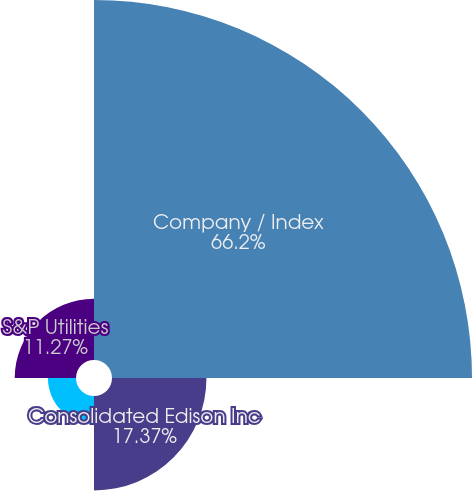Convert chart to OTSL. <chart><loc_0><loc_0><loc_500><loc_500><pie_chart><fcel>Company / Index<fcel>Consolidated Edison Inc<fcel>S&P 500 Index<fcel>S&P Utilities<nl><fcel>66.2%<fcel>17.37%<fcel>5.16%<fcel>11.27%<nl></chart> 